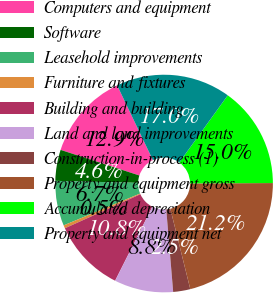Convert chart. <chart><loc_0><loc_0><loc_500><loc_500><pie_chart><fcel>Computers and equipment<fcel>Software<fcel>Leasehold improvements<fcel>Furniture and fixtures<fcel>Building and building<fcel>Land and land improvements<fcel>Construction-in-process (1)<fcel>Property and equipment gross<fcel>Accumulated depreciation<fcel>Property and equipment net<nl><fcel>12.9%<fcel>4.61%<fcel>6.68%<fcel>0.46%<fcel>10.83%<fcel>8.76%<fcel>2.54%<fcel>21.2%<fcel>14.98%<fcel>17.05%<nl></chart> 